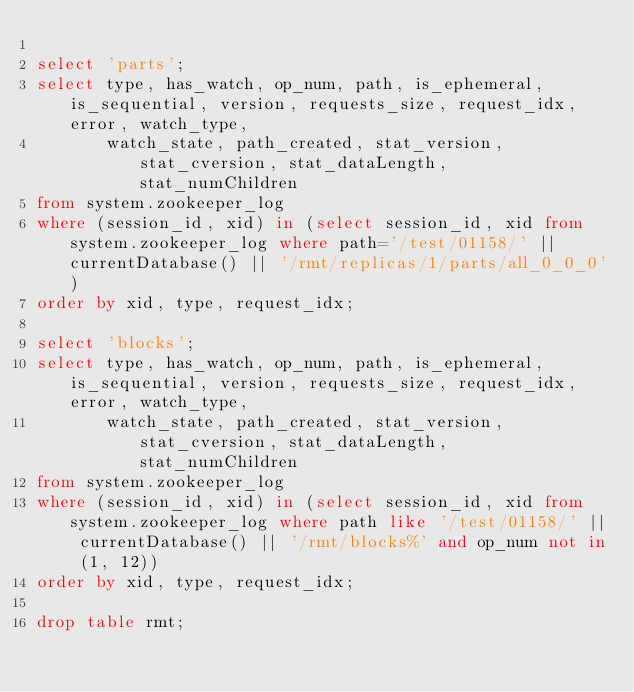<code> <loc_0><loc_0><loc_500><loc_500><_SQL_>
select 'parts';
select type, has_watch, op_num, path, is_ephemeral, is_sequential, version, requests_size, request_idx, error, watch_type,
       watch_state, path_created, stat_version, stat_cversion, stat_dataLength, stat_numChildren
from system.zookeeper_log
where (session_id, xid) in (select session_id, xid from system.zookeeper_log where path='/test/01158/' || currentDatabase() || '/rmt/replicas/1/parts/all_0_0_0')
order by xid, type, request_idx;

select 'blocks';
select type, has_watch, op_num, path, is_ephemeral, is_sequential, version, requests_size, request_idx, error, watch_type,
       watch_state, path_created, stat_version, stat_cversion, stat_dataLength, stat_numChildren
from system.zookeeper_log
where (session_id, xid) in (select session_id, xid from system.zookeeper_log where path like '/test/01158/' || currentDatabase() || '/rmt/blocks%' and op_num not in (1, 12))
order by xid, type, request_idx;

drop table rmt;
</code> 